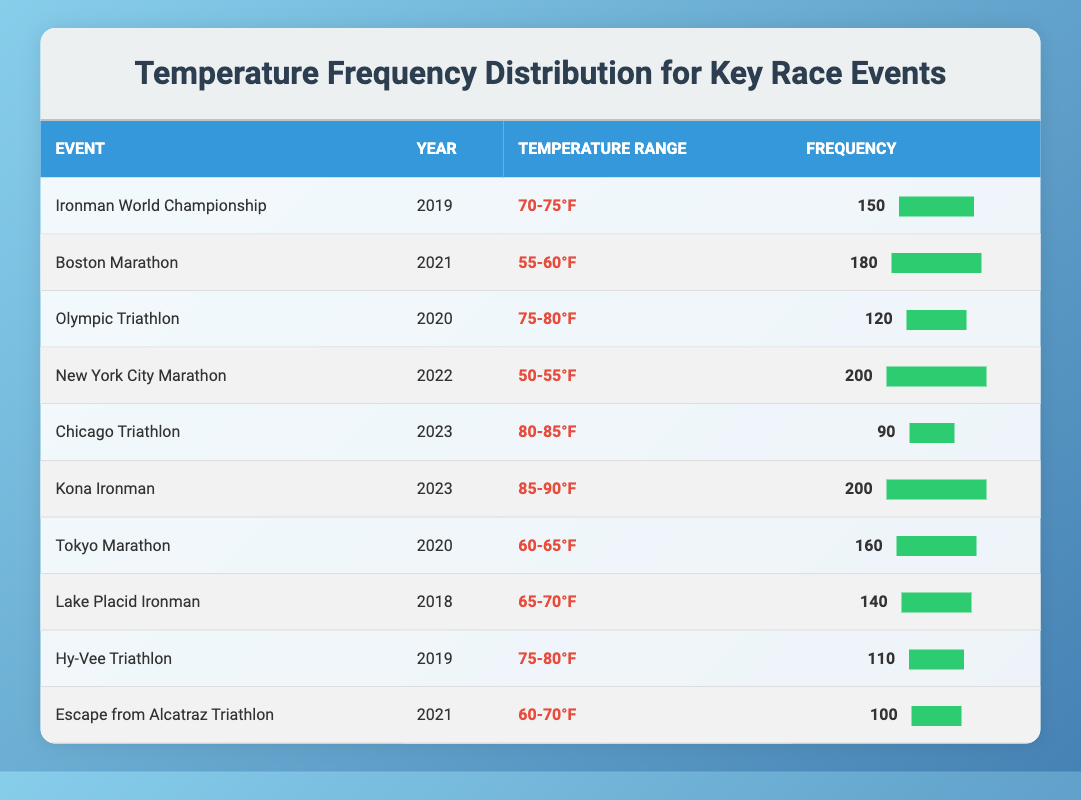What temperature range had the highest frequency in the table? The event with the highest frequency is the "New York City Marathon" with a frequency of 200, occurring in the temperature range of "50-55°F".
Answer: 50-55°F How many events had a frequency of 150 or more? The events with frequencies of 150 or more are: Ironman World Championship (150), Boston Marathon (180), New York City Marathon (200), Kona Ironman (200), and Tokyo Marathon (160). In total, that makes 5 events.
Answer: 5 Which event recorded the lowest frequency and what was that frequency? The event with the lowest frequency is the "Chicago Triathlon" with a frequency of 90.
Answer: 90 Is the average frequency of events taking place in 2023 higher than that of events in 2019? The frequencies for 2023 are 90 (Chicago Triathlon) and 200 (Kona Ironman), summing to 290 for an average of 145. The frequencies for 2019 are 150 (Ironman World Championship) and 110 (Hy-Vee Triathlon), summing to 260 for an average of 130. Since 145 is greater than 130, the average frequency for 2023 is higher.
Answer: Yes How does the total frequency of events with temperature ranges of 75-80°F compare to those with temperature ranges of 60-65°F? For 75-80°F, the events are Olympic Triathlon (120) and Hy-Vee Triathlon (110), totaling 230. For 60-65°F, only the Tokyo Marathon recorded 160. Since 230 is greater than 160, 75-80°F has a higher total frequency.
Answer: 75-80°F is higher 